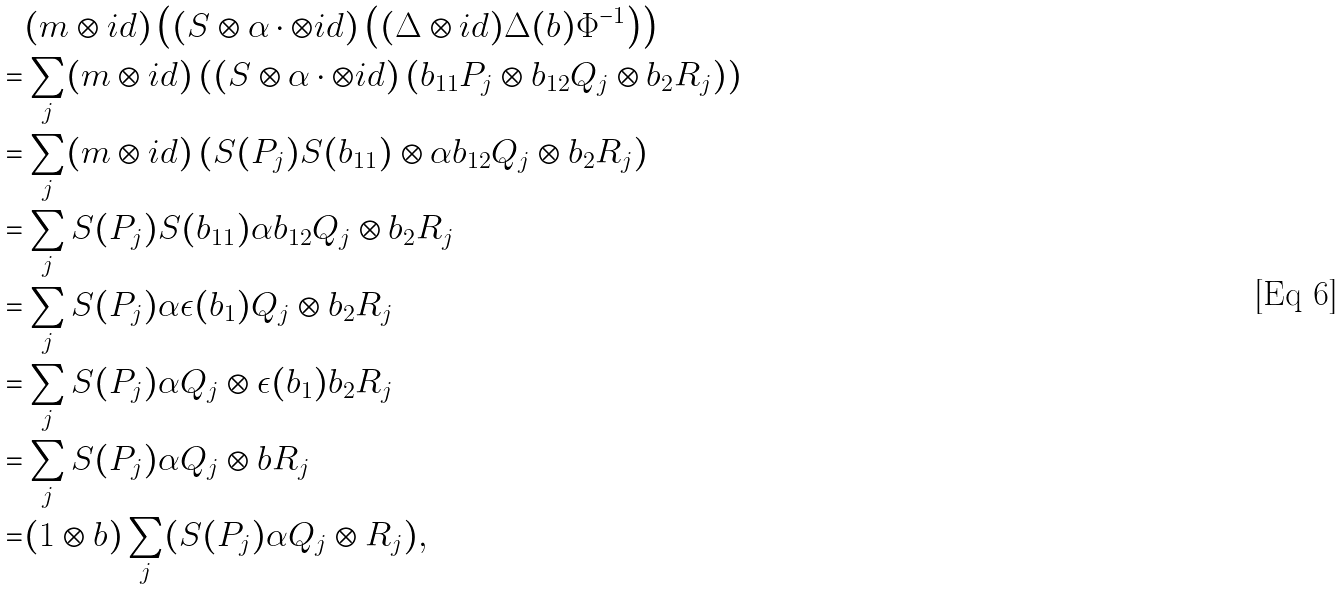Convert formula to latex. <formula><loc_0><loc_0><loc_500><loc_500>& ( m \otimes i d ) \left ( ( S \otimes \alpha \cdot \otimes i d ) \left ( ( \Delta \otimes i d ) \Delta ( b ) \Phi ^ { - 1 } \right ) \right ) \\ = & \sum _ { j } ( m \otimes i d ) \left ( ( S \otimes \alpha \cdot \otimes i d ) \left ( b _ { 1 1 } P _ { j } \otimes b _ { 1 2 } Q _ { j } \otimes b _ { 2 } R _ { j } \right ) \right ) \\ = & \sum _ { j } ( m \otimes i d ) \left ( S ( P _ { j } ) S ( b _ { 1 1 } ) \otimes \alpha b _ { 1 2 } Q _ { j } \otimes b _ { 2 } R _ { j } \right ) \\ = & \sum _ { j } S ( P _ { j } ) S ( b _ { 1 1 } ) \alpha b _ { 1 2 } Q _ { j } \otimes b _ { 2 } R _ { j } \\ = & \sum _ { j } S ( P _ { j } ) \alpha \epsilon ( b _ { 1 } ) Q _ { j } \otimes b _ { 2 } R _ { j } \\ = & \sum _ { j } S ( P _ { j } ) \alpha Q _ { j } \otimes \epsilon ( b _ { 1 } ) b _ { 2 } R _ { j } \\ = & \sum _ { j } S ( P _ { j } ) \alpha Q _ { j } \otimes b R _ { j } \\ = & ( 1 \otimes b ) \sum _ { j } ( S ( P _ { j } ) \alpha Q _ { j } \otimes R _ { j } ) ,</formula> 